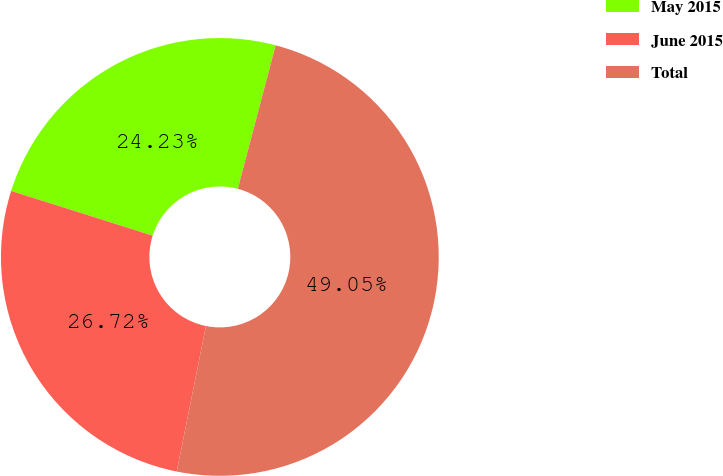Convert chart. <chart><loc_0><loc_0><loc_500><loc_500><pie_chart><fcel>May 2015<fcel>June 2015<fcel>Total<nl><fcel>24.23%<fcel>26.72%<fcel>49.05%<nl></chart> 